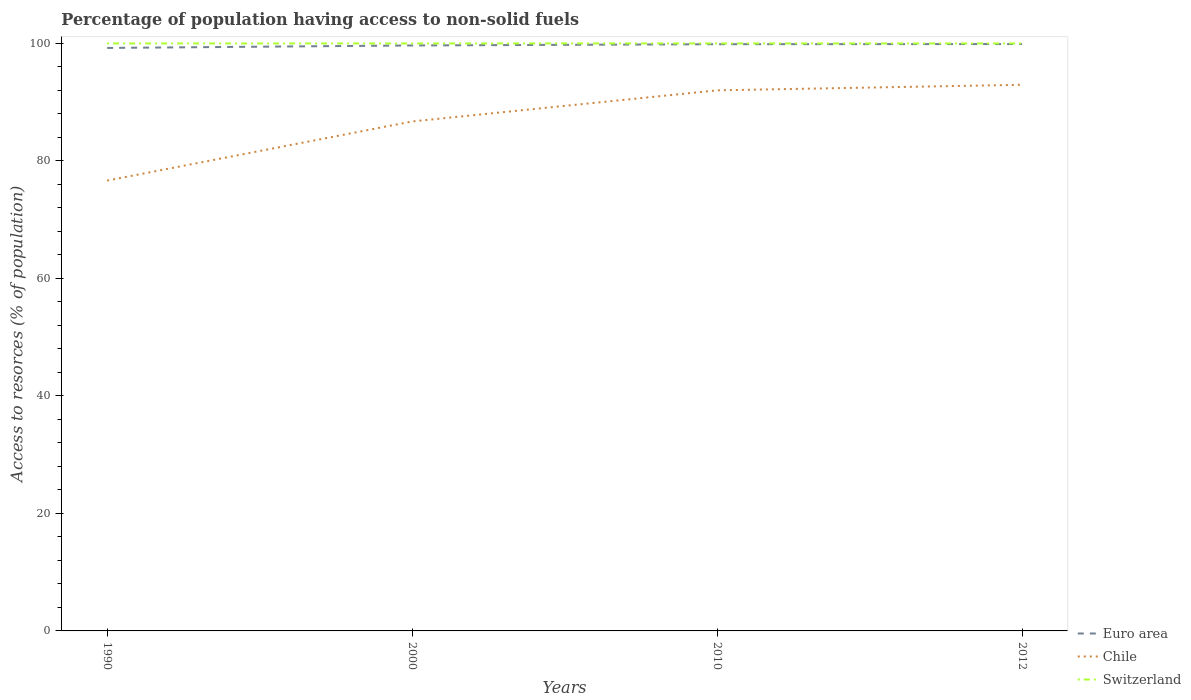Is the number of lines equal to the number of legend labels?
Your answer should be very brief. Yes. Across all years, what is the maximum percentage of population having access to non-solid fuels in Euro area?
Make the answer very short. 99.23. In which year was the percentage of population having access to non-solid fuels in Euro area maximum?
Your response must be concise. 1990. What is the difference between the highest and the second highest percentage of population having access to non-solid fuels in Chile?
Ensure brevity in your answer.  16.3. Is the percentage of population having access to non-solid fuels in Switzerland strictly greater than the percentage of population having access to non-solid fuels in Chile over the years?
Your answer should be compact. No. How many lines are there?
Offer a very short reply. 3. How many years are there in the graph?
Provide a short and direct response. 4. What is the difference between two consecutive major ticks on the Y-axis?
Your answer should be very brief. 20. Does the graph contain any zero values?
Your response must be concise. No. Does the graph contain grids?
Make the answer very short. No. How many legend labels are there?
Offer a terse response. 3. How are the legend labels stacked?
Offer a very short reply. Vertical. What is the title of the graph?
Make the answer very short. Percentage of population having access to non-solid fuels. What is the label or title of the X-axis?
Your answer should be compact. Years. What is the label or title of the Y-axis?
Offer a terse response. Access to resorces (% of population). What is the Access to resorces (% of population) in Euro area in 1990?
Give a very brief answer. 99.23. What is the Access to resorces (% of population) in Chile in 1990?
Keep it short and to the point. 76.66. What is the Access to resorces (% of population) of Switzerland in 1990?
Provide a short and direct response. 100. What is the Access to resorces (% of population) of Euro area in 2000?
Keep it short and to the point. 99.66. What is the Access to resorces (% of population) of Chile in 2000?
Your response must be concise. 86.72. What is the Access to resorces (% of population) in Switzerland in 2000?
Provide a short and direct response. 100. What is the Access to resorces (% of population) of Euro area in 2010?
Offer a terse response. 99.87. What is the Access to resorces (% of population) of Chile in 2010?
Your response must be concise. 92.02. What is the Access to resorces (% of population) in Switzerland in 2010?
Offer a very short reply. 100. What is the Access to resorces (% of population) in Euro area in 2012?
Keep it short and to the point. 99.89. What is the Access to resorces (% of population) of Chile in 2012?
Provide a short and direct response. 92.96. Across all years, what is the maximum Access to resorces (% of population) in Euro area?
Provide a short and direct response. 99.89. Across all years, what is the maximum Access to resorces (% of population) of Chile?
Give a very brief answer. 92.96. Across all years, what is the maximum Access to resorces (% of population) in Switzerland?
Give a very brief answer. 100. Across all years, what is the minimum Access to resorces (% of population) in Euro area?
Make the answer very short. 99.23. Across all years, what is the minimum Access to resorces (% of population) in Chile?
Your answer should be compact. 76.66. Across all years, what is the minimum Access to resorces (% of population) in Switzerland?
Ensure brevity in your answer.  100. What is the total Access to resorces (% of population) of Euro area in the graph?
Make the answer very short. 398.65. What is the total Access to resorces (% of population) of Chile in the graph?
Your response must be concise. 348.35. What is the total Access to resorces (% of population) in Switzerland in the graph?
Your answer should be compact. 400. What is the difference between the Access to resorces (% of population) of Euro area in 1990 and that in 2000?
Offer a terse response. -0.42. What is the difference between the Access to resorces (% of population) in Chile in 1990 and that in 2000?
Offer a very short reply. -10.06. What is the difference between the Access to resorces (% of population) in Euro area in 1990 and that in 2010?
Provide a short and direct response. -0.64. What is the difference between the Access to resorces (% of population) in Chile in 1990 and that in 2010?
Offer a terse response. -15.36. What is the difference between the Access to resorces (% of population) in Switzerland in 1990 and that in 2010?
Your answer should be very brief. 0. What is the difference between the Access to resorces (% of population) in Euro area in 1990 and that in 2012?
Offer a very short reply. -0.66. What is the difference between the Access to resorces (% of population) of Chile in 1990 and that in 2012?
Offer a very short reply. -16.3. What is the difference between the Access to resorces (% of population) of Euro area in 2000 and that in 2010?
Provide a succinct answer. -0.21. What is the difference between the Access to resorces (% of population) of Chile in 2000 and that in 2010?
Offer a very short reply. -5.3. What is the difference between the Access to resorces (% of population) of Euro area in 2000 and that in 2012?
Give a very brief answer. -0.24. What is the difference between the Access to resorces (% of population) of Chile in 2000 and that in 2012?
Make the answer very short. -6.24. What is the difference between the Access to resorces (% of population) of Switzerland in 2000 and that in 2012?
Your answer should be very brief. 0. What is the difference between the Access to resorces (% of population) of Euro area in 2010 and that in 2012?
Make the answer very short. -0.02. What is the difference between the Access to resorces (% of population) of Chile in 2010 and that in 2012?
Provide a short and direct response. -0.94. What is the difference between the Access to resorces (% of population) in Switzerland in 2010 and that in 2012?
Provide a succinct answer. 0. What is the difference between the Access to resorces (% of population) of Euro area in 1990 and the Access to resorces (% of population) of Chile in 2000?
Provide a succinct answer. 12.51. What is the difference between the Access to resorces (% of population) of Euro area in 1990 and the Access to resorces (% of population) of Switzerland in 2000?
Your answer should be compact. -0.77. What is the difference between the Access to resorces (% of population) of Chile in 1990 and the Access to resorces (% of population) of Switzerland in 2000?
Your answer should be very brief. -23.34. What is the difference between the Access to resorces (% of population) in Euro area in 1990 and the Access to resorces (% of population) in Chile in 2010?
Your answer should be very brief. 7.22. What is the difference between the Access to resorces (% of population) of Euro area in 1990 and the Access to resorces (% of population) of Switzerland in 2010?
Ensure brevity in your answer.  -0.77. What is the difference between the Access to resorces (% of population) of Chile in 1990 and the Access to resorces (% of population) of Switzerland in 2010?
Your response must be concise. -23.34. What is the difference between the Access to resorces (% of population) in Euro area in 1990 and the Access to resorces (% of population) in Chile in 2012?
Provide a succinct answer. 6.27. What is the difference between the Access to resorces (% of population) in Euro area in 1990 and the Access to resorces (% of population) in Switzerland in 2012?
Offer a very short reply. -0.77. What is the difference between the Access to resorces (% of population) of Chile in 1990 and the Access to resorces (% of population) of Switzerland in 2012?
Your response must be concise. -23.34. What is the difference between the Access to resorces (% of population) of Euro area in 2000 and the Access to resorces (% of population) of Chile in 2010?
Offer a terse response. 7.64. What is the difference between the Access to resorces (% of population) of Euro area in 2000 and the Access to resorces (% of population) of Switzerland in 2010?
Your response must be concise. -0.34. What is the difference between the Access to resorces (% of population) in Chile in 2000 and the Access to resorces (% of population) in Switzerland in 2010?
Keep it short and to the point. -13.28. What is the difference between the Access to resorces (% of population) in Euro area in 2000 and the Access to resorces (% of population) in Chile in 2012?
Offer a terse response. 6.69. What is the difference between the Access to resorces (% of population) in Euro area in 2000 and the Access to resorces (% of population) in Switzerland in 2012?
Your response must be concise. -0.34. What is the difference between the Access to resorces (% of population) in Chile in 2000 and the Access to resorces (% of population) in Switzerland in 2012?
Your answer should be compact. -13.28. What is the difference between the Access to resorces (% of population) in Euro area in 2010 and the Access to resorces (% of population) in Chile in 2012?
Give a very brief answer. 6.91. What is the difference between the Access to resorces (% of population) in Euro area in 2010 and the Access to resorces (% of population) in Switzerland in 2012?
Provide a short and direct response. -0.13. What is the difference between the Access to resorces (% of population) in Chile in 2010 and the Access to resorces (% of population) in Switzerland in 2012?
Your answer should be very brief. -7.98. What is the average Access to resorces (% of population) in Euro area per year?
Your response must be concise. 99.66. What is the average Access to resorces (% of population) of Chile per year?
Provide a short and direct response. 87.09. In the year 1990, what is the difference between the Access to resorces (% of population) of Euro area and Access to resorces (% of population) of Chile?
Make the answer very short. 22.58. In the year 1990, what is the difference between the Access to resorces (% of population) of Euro area and Access to resorces (% of population) of Switzerland?
Ensure brevity in your answer.  -0.77. In the year 1990, what is the difference between the Access to resorces (% of population) in Chile and Access to resorces (% of population) in Switzerland?
Ensure brevity in your answer.  -23.34. In the year 2000, what is the difference between the Access to resorces (% of population) in Euro area and Access to resorces (% of population) in Chile?
Your answer should be very brief. 12.94. In the year 2000, what is the difference between the Access to resorces (% of population) in Euro area and Access to resorces (% of population) in Switzerland?
Make the answer very short. -0.34. In the year 2000, what is the difference between the Access to resorces (% of population) in Chile and Access to resorces (% of population) in Switzerland?
Ensure brevity in your answer.  -13.28. In the year 2010, what is the difference between the Access to resorces (% of population) in Euro area and Access to resorces (% of population) in Chile?
Give a very brief answer. 7.85. In the year 2010, what is the difference between the Access to resorces (% of population) in Euro area and Access to resorces (% of population) in Switzerland?
Make the answer very short. -0.13. In the year 2010, what is the difference between the Access to resorces (% of population) in Chile and Access to resorces (% of population) in Switzerland?
Keep it short and to the point. -7.98. In the year 2012, what is the difference between the Access to resorces (% of population) of Euro area and Access to resorces (% of population) of Chile?
Offer a terse response. 6.93. In the year 2012, what is the difference between the Access to resorces (% of population) in Euro area and Access to resorces (% of population) in Switzerland?
Your answer should be compact. -0.11. In the year 2012, what is the difference between the Access to resorces (% of population) in Chile and Access to resorces (% of population) in Switzerland?
Ensure brevity in your answer.  -7.04. What is the ratio of the Access to resorces (% of population) in Chile in 1990 to that in 2000?
Ensure brevity in your answer.  0.88. What is the ratio of the Access to resorces (% of population) of Switzerland in 1990 to that in 2000?
Give a very brief answer. 1. What is the ratio of the Access to resorces (% of population) in Euro area in 1990 to that in 2010?
Provide a succinct answer. 0.99. What is the ratio of the Access to resorces (% of population) in Chile in 1990 to that in 2010?
Give a very brief answer. 0.83. What is the ratio of the Access to resorces (% of population) of Switzerland in 1990 to that in 2010?
Ensure brevity in your answer.  1. What is the ratio of the Access to resorces (% of population) in Euro area in 1990 to that in 2012?
Provide a short and direct response. 0.99. What is the ratio of the Access to resorces (% of population) of Chile in 1990 to that in 2012?
Offer a very short reply. 0.82. What is the ratio of the Access to resorces (% of population) in Switzerland in 1990 to that in 2012?
Keep it short and to the point. 1. What is the ratio of the Access to resorces (% of population) of Euro area in 2000 to that in 2010?
Make the answer very short. 1. What is the ratio of the Access to resorces (% of population) of Chile in 2000 to that in 2010?
Your answer should be very brief. 0.94. What is the ratio of the Access to resorces (% of population) of Switzerland in 2000 to that in 2010?
Your answer should be compact. 1. What is the ratio of the Access to resorces (% of population) in Chile in 2000 to that in 2012?
Provide a succinct answer. 0.93. What is the ratio of the Access to resorces (% of population) in Switzerland in 2000 to that in 2012?
Offer a terse response. 1. What is the ratio of the Access to resorces (% of population) of Euro area in 2010 to that in 2012?
Your response must be concise. 1. What is the difference between the highest and the second highest Access to resorces (% of population) of Euro area?
Offer a very short reply. 0.02. What is the difference between the highest and the second highest Access to resorces (% of population) in Chile?
Offer a very short reply. 0.94. What is the difference between the highest and the second highest Access to resorces (% of population) in Switzerland?
Give a very brief answer. 0. What is the difference between the highest and the lowest Access to resorces (% of population) of Euro area?
Give a very brief answer. 0.66. What is the difference between the highest and the lowest Access to resorces (% of population) in Chile?
Give a very brief answer. 16.3. 